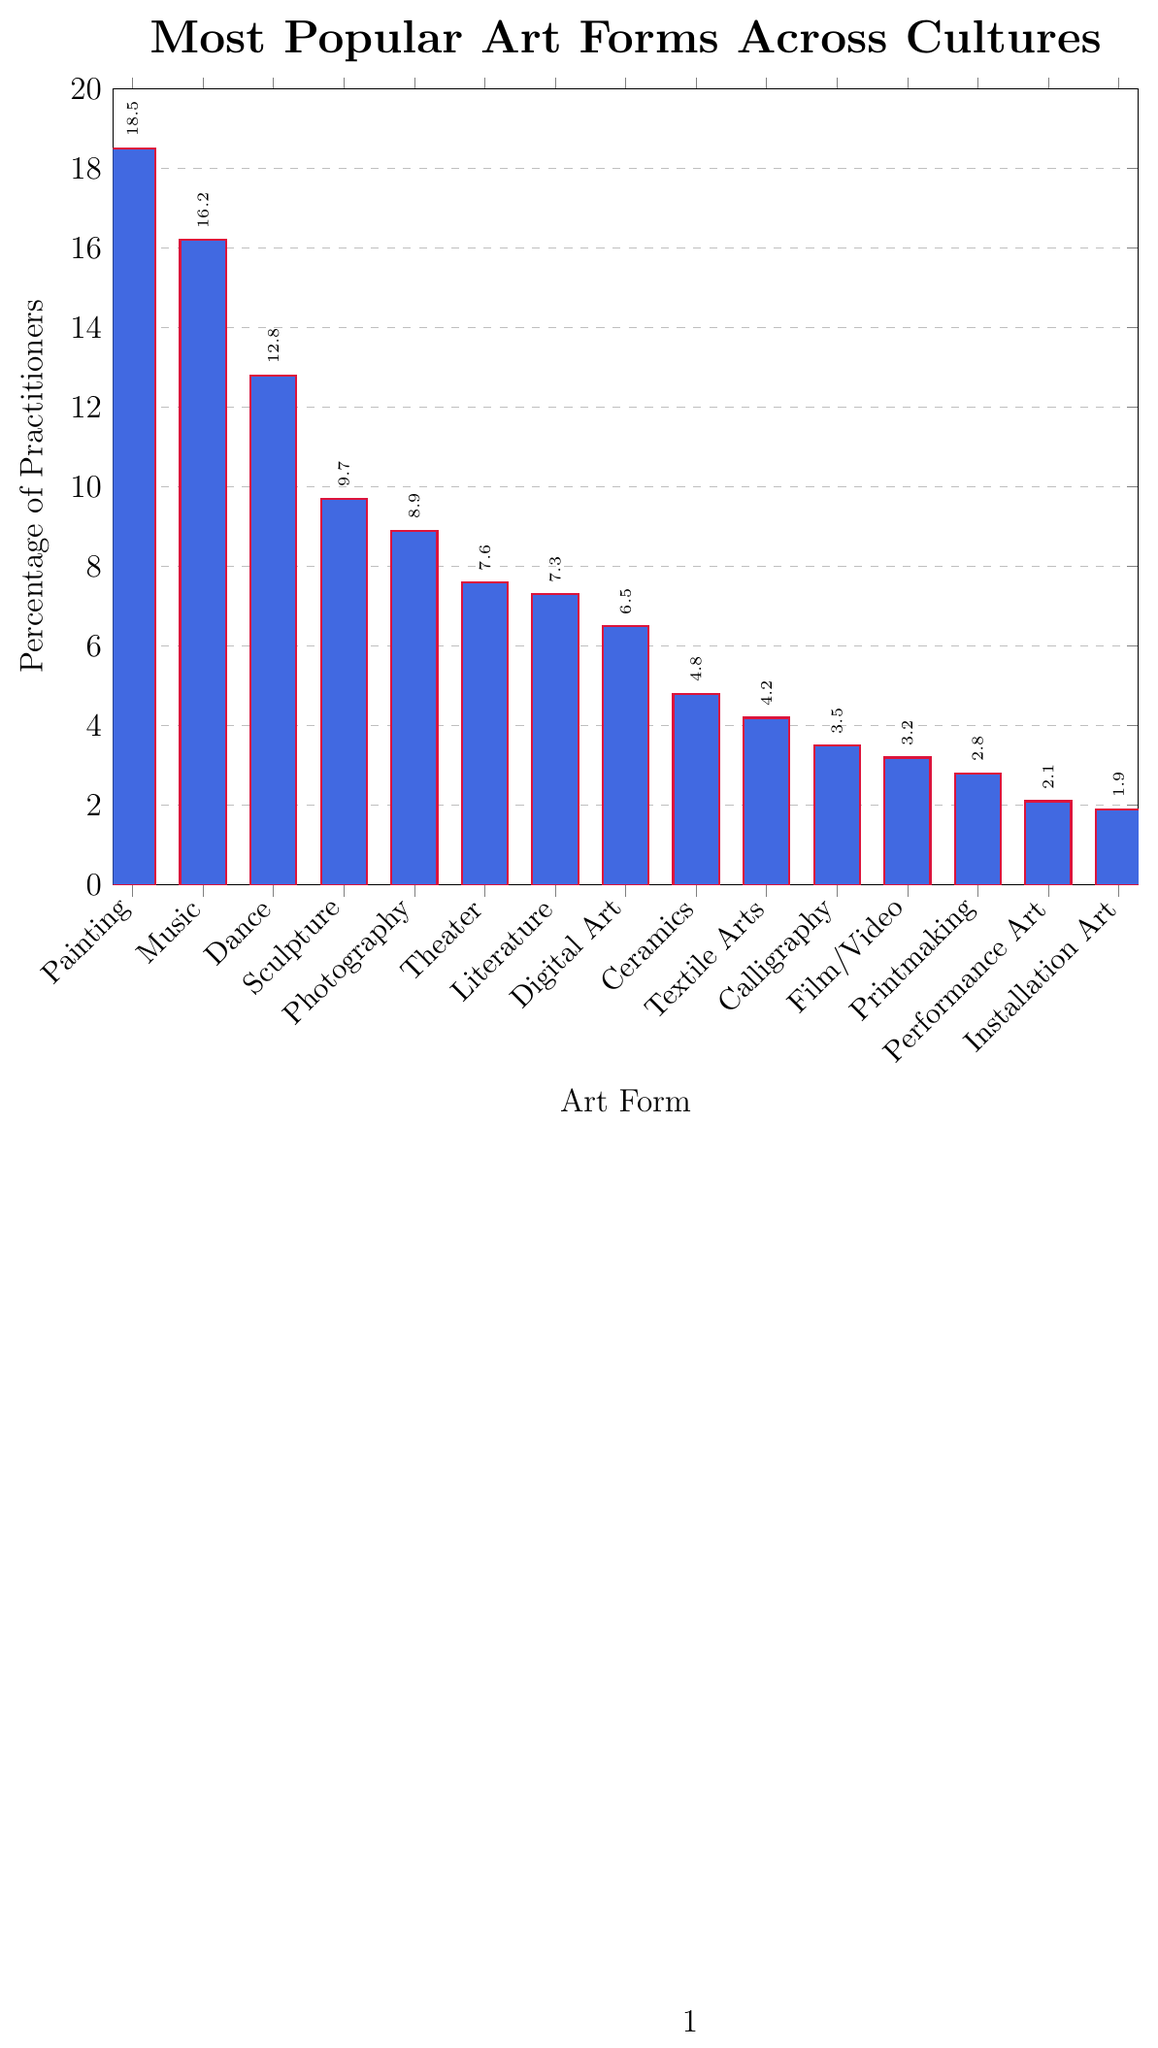What is the most popular art form according to the chart? Look at the bar with the highest value. The tallest bar corresponds to Painting with 18.5% of practitioners.
Answer: Painting Which art form has a higher percentage of practitioners, Dance or Sculpture? Compare the heights of the bars for Dance and Sculpture. Dance has 12.8%, and Sculpture has 9.7%. Dance is higher.
Answer: Dance What is the combined percentage of practitioners for Digital Art and Photography? Find the percentage values for both Digital Art (6.5%) and Photography (8.9%), then add them together: 6.5 + 8.9 = 15.4
Answer: 15.4% Which art form has fewer practitioners, Literature or Ceramics? Compare the values for Literature (7.3%) and Ceramics (4.8%). Ceramics has fewer practitioners.
Answer: Ceramics Among the art forms listed, which has the lowest percentage of practitioners? Identify the bar with the smallest value. The shortest bar corresponds to Installation Art with 1.9%.
Answer: Installation Art What is the percentage difference between Music and Theater? Subtract the percentage of Theater (7.6%) from the percentage of Music (16.2%): 16.2 - 7.6 = 8.6
Answer: 8.6% Which two art forms together account for approximately 30% of practitioners? Identify pairs of art forms whose combined percentages add up to around 30%. Painting (18.5%) and Dance (12.8%) together make 31.3%, which is the closest.
Answer: Painting and Dance How does the number of practitioners for Film/Video compare to Calligraphy? Compare the values for Film/Video (3.2%) and Calligraphy (3.5%). Calligraphy has a slightly higher percentage.
Answer: Calligraphy What is the average percentage of practitioners for the top three art forms? Identify the top three art forms Painting (18.5%), Music (16.2%), and Dance (12.8%). Calculate the average: (18.5 + 16.2 + 12.8) / 3 = 15.83
Answer: 15.83% Is Photography more popular than Literature? Compare the values of Photography (8.9%) and Literature (7.3%). Photography has a higher percentage.
Answer: Yes 